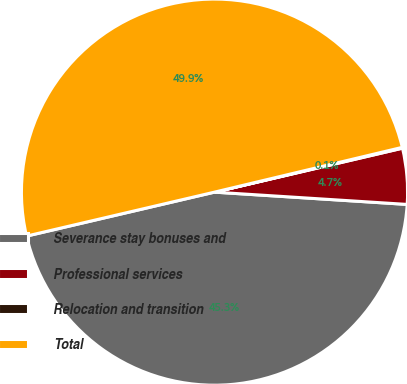Convert chart to OTSL. <chart><loc_0><loc_0><loc_500><loc_500><pie_chart><fcel>Severance stay bonuses and<fcel>Professional services<fcel>Relocation and transition<fcel>Total<nl><fcel>45.33%<fcel>4.67%<fcel>0.07%<fcel>49.93%<nl></chart> 